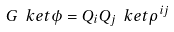<formula> <loc_0><loc_0><loc_500><loc_500>G \ k e t { \phi } = Q _ { i } Q _ { j } \ k e t { \rho ^ { i j } }</formula> 